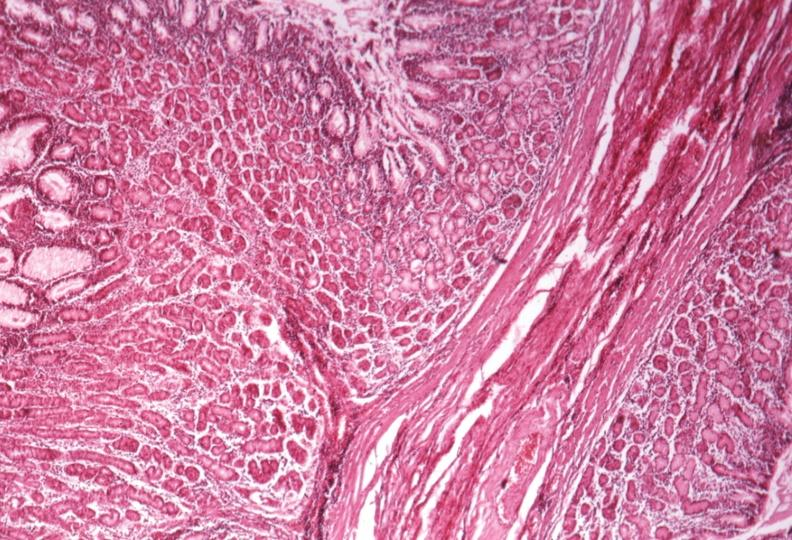s feet present?
Answer the question using a single word or phrase. No 